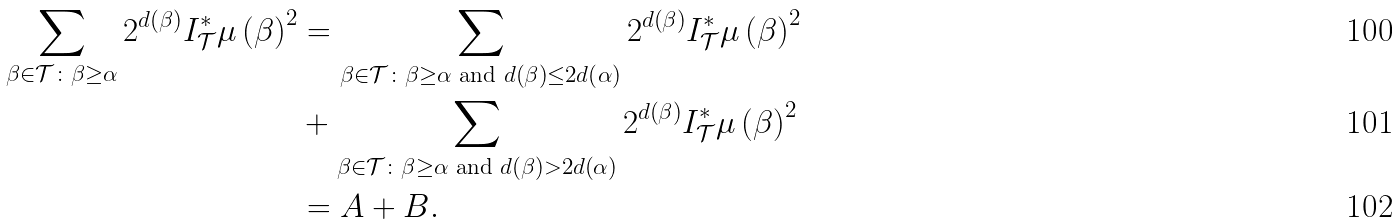Convert formula to latex. <formula><loc_0><loc_0><loc_500><loc_500>\sum _ { \beta \in \mathcal { T } \colon \beta \geq \alpha } 2 ^ { d \left ( \beta \right ) } I _ { \mathcal { T } } ^ { \ast } \mu \left ( \beta \right ) ^ { 2 } & = \sum _ { \beta \in \mathcal { T } \colon \beta \geq \alpha \text { and } d \left ( \beta \right ) \leq 2 d \left ( \alpha \right ) } 2 ^ { d \left ( \beta \right ) } I _ { \mathcal { T } } ^ { \ast } \mu \left ( \beta \right ) ^ { 2 } \\ & + \sum _ { \beta \in \mathcal { T } \colon \beta \geq \alpha \text { and } d \left ( \beta \right ) > 2 d \left ( \alpha \right ) } 2 ^ { d \left ( \beta \right ) } I _ { \mathcal { T } } ^ { \ast } \mu \left ( \beta \right ) ^ { 2 } \\ & = A + B .</formula> 